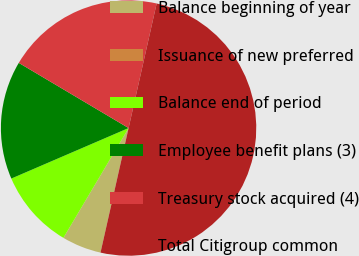Convert chart. <chart><loc_0><loc_0><loc_500><loc_500><pie_chart><fcel>Balance beginning of year<fcel>Issuance of new preferred<fcel>Balance end of period<fcel>Employee benefit plans (3)<fcel>Treasury stock acquired (4)<fcel>Total Citigroup common<nl><fcel>5.0%<fcel>0.0%<fcel>10.0%<fcel>15.0%<fcel>20.0%<fcel>50.0%<nl></chart> 